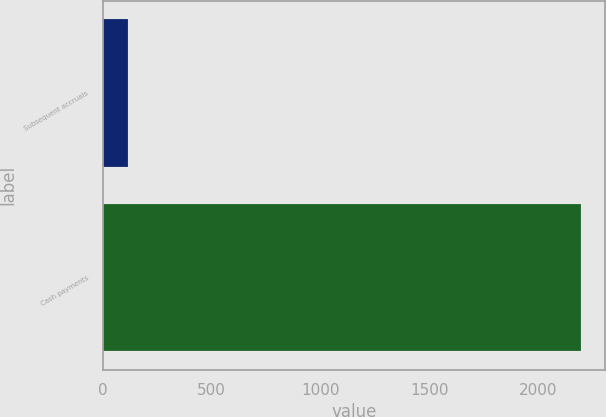<chart> <loc_0><loc_0><loc_500><loc_500><bar_chart><fcel>Subsequent accruals<fcel>Cash payments<nl><fcel>119<fcel>2196<nl></chart> 